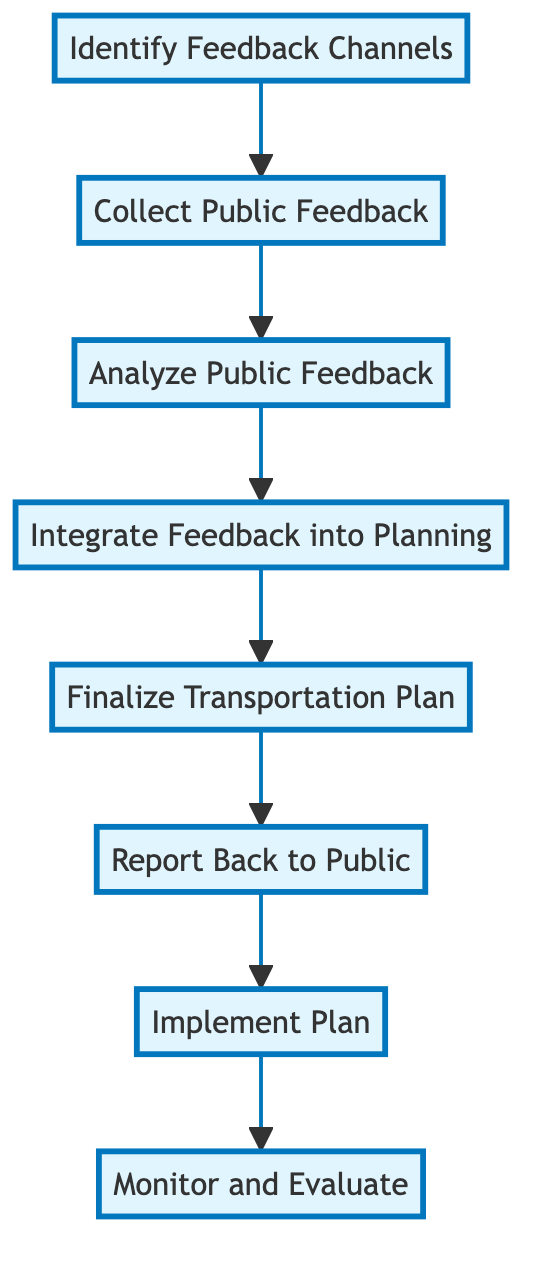What is the first step in the process? The first step is "Identify Feedback Channels," which is the starting point of the flowchart that lays the foundation for collecting public feedback.
Answer: Identify Feedback Channels How many total steps are there? There are eight steps in the flowchart, starting from "Identify Feedback Channels" and ending with "Monitor and Evaluate."
Answer: 8 What follows "Collect Public Feedback"? The step that follows "Collect Public Feedback" is "Analyze Public Feedback," indicating the next action taken after gathering feedback.
Answer: Analyze Public Feedback Which step is directly related to the transportation plan? The step directly related to the transportation plan is "Finalize Transportation Plan," as it focuses on developing and approving the plan that incorporates public feedback.
Answer: Finalize Transportation Plan What is the outcome of "Monitor and Evaluate"? The outcome of "Monitor and Evaluate" is ongoing adjustments to the transportation plan based on new feedback and data, as it is the final step ensuring continuous improvement.
Answer: Continuous improvement Explain the relationship between "Integrate Feedback into Planning" and "Report Back to Public." "Integrate Feedback into Planning" occurs before "Report Back to Public." After incorporating public feedback into the planning, the next action is to communicate the changes back to the public, showing the flow from feedback integration to public reporting.
Answer: Feedback integration to public reporting What is the overall direction of the flowchart? The overall direction of the flowchart flows from bottom to up, indicating that each step builds upon the previous one, creating a sequential process for integrating public feedback.
Answer: Bottom to up How does "Implement Plan" contribute to the overall process? "Implement Plan" is crucial as it executes the finalized transportation plan while allowing for necessary adjustments based on ongoing feedback, thus ensuring the plan remains effective and responsive.
Answer: Ensures effectiveness and responsiveness 